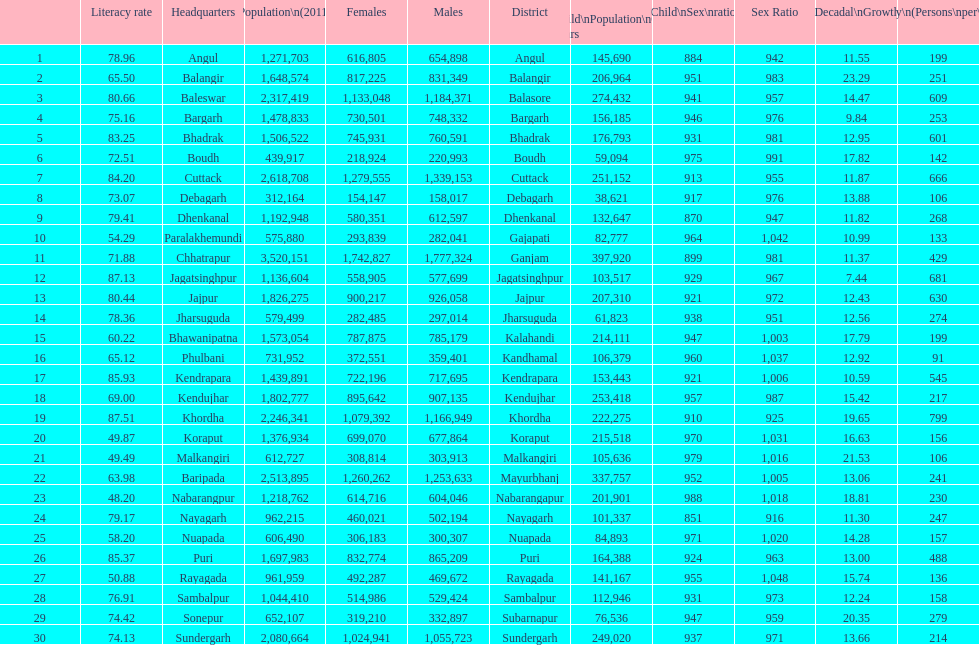Which district had the most people per km? Khordha. 